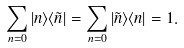<formula> <loc_0><loc_0><loc_500><loc_500>\sum _ { n = 0 } | n \rangle \langle \tilde { n } | = \sum _ { n = 0 } | \tilde { n } \rangle \langle { n } | = { 1 } .</formula> 